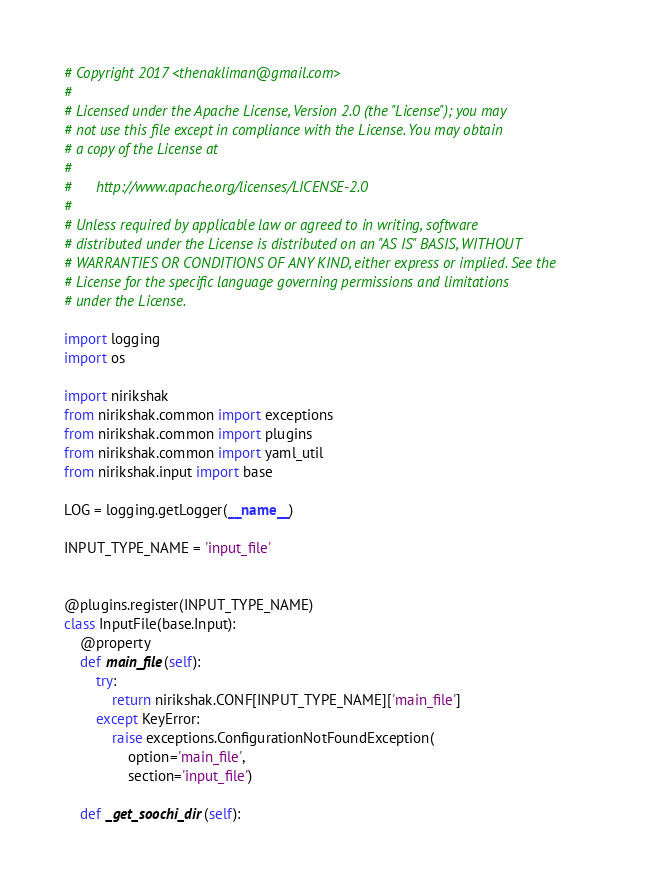Convert code to text. <code><loc_0><loc_0><loc_500><loc_500><_Python_># Copyright 2017 <thenakliman@gmail.com>
#
# Licensed under the Apache License, Version 2.0 (the "License"); you may
# not use this file except in compliance with the License. You may obtain
# a copy of the License at
#
#      http://www.apache.org/licenses/LICENSE-2.0
#
# Unless required by applicable law or agreed to in writing, software
# distributed under the License is distributed on an "AS IS" BASIS, WITHOUT
# WARRANTIES OR CONDITIONS OF ANY KIND, either express or implied. See the
# License for the specific language governing permissions and limitations
# under the License.

import logging
import os

import nirikshak
from nirikshak.common import exceptions
from nirikshak.common import plugins
from nirikshak.common import yaml_util
from nirikshak.input import base

LOG = logging.getLogger(__name__)

INPUT_TYPE_NAME = 'input_file'


@plugins.register(INPUT_TYPE_NAME)
class InputFile(base.Input):
    @property
    def main_file(self):
        try:
            return nirikshak.CONF[INPUT_TYPE_NAME]['main_file']
        except KeyError:
            raise exceptions.ConfigurationNotFoundException(
                option='main_file',
                section='input_file')

    def _get_soochi_dir(self):</code> 